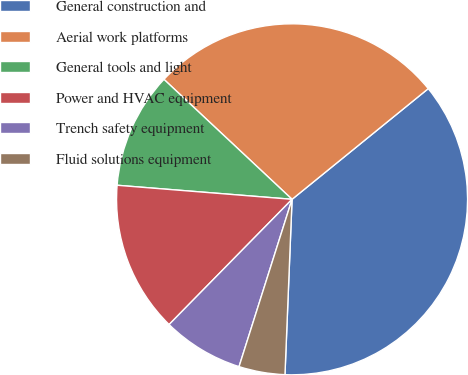Convert chart to OTSL. <chart><loc_0><loc_0><loc_500><loc_500><pie_chart><fcel>General construction and<fcel>Aerial work platforms<fcel>General tools and light<fcel>Power and HVAC equipment<fcel>Trench safety equipment<fcel>Fluid solutions equipment<nl><fcel>36.5%<fcel>27.16%<fcel>10.7%<fcel>13.92%<fcel>7.47%<fcel>4.24%<nl></chart> 